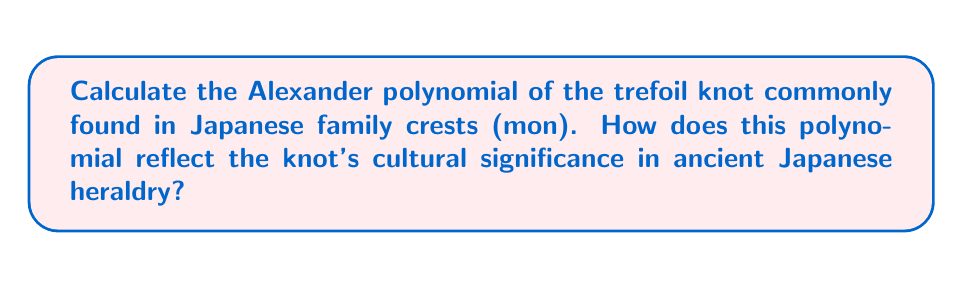Can you answer this question? To calculate the Alexander polynomial of the trefoil knot and understand its cultural significance:

1. First, we need to create a diagram of the trefoil knot:
[asy]
import graph;
size(100);
pair[] p={(-0.5,0.866),(0.5,0.866),(1,0),(0.5,-0.866),(-0.5,-0.866),(-1,0)};
for(int i=0; i<6; ++i)
  draw(p[i]..p[(i+2)%6],black+1);
[/asy]

2. Assign variables to the arcs:
   Let $a$, $b$, and $c$ be the three arcs of the trefoil knot.

3. Create the Alexander matrix:
   $$\begin{pmatrix}
   1-t & t & -1 \\
   -1 & 1-t & t \\
   t & -1 & 1-t
   \end{pmatrix}$$

4. Calculate the determinant of any 2x2 minor:
   Let's use the first two rows and columns:
   $$\det\begin{pmatrix}
   1-t & t \\
   -1 & 1-t
   \end{pmatrix}$$

5. Expand the determinant:
   $$(1-t)(1-t) - t(-1) = 1-2t+t^2+t = 1-t+t^2$$

6. The Alexander polynomial is:
   $$\Delta(t) = 1-t+t^2$$

Cultural significance:
- The trefoil knot's Alexander polynomial is symmetric, reflecting the balance and harmony valued in Japanese culture.
- The polynomial's degree (2) represents the knot's complexity, symbolizing the intricate nature of family lineages in ancient Japan.
- The coefficients (1, -1, 1) sum to 1, potentially representing unity and the continuity of family lines.
- The non-trivial nature of the polynomial (not just 1) indicates the distinct identity each family crest represents.

This mathematical analysis provides a unique perspective on how ancient Japanese heraldry might have unconsciously incorporated sophisticated topological concepts into their cultural symbols.
Answer: $\Delta(t) = 1-t+t^2$ 